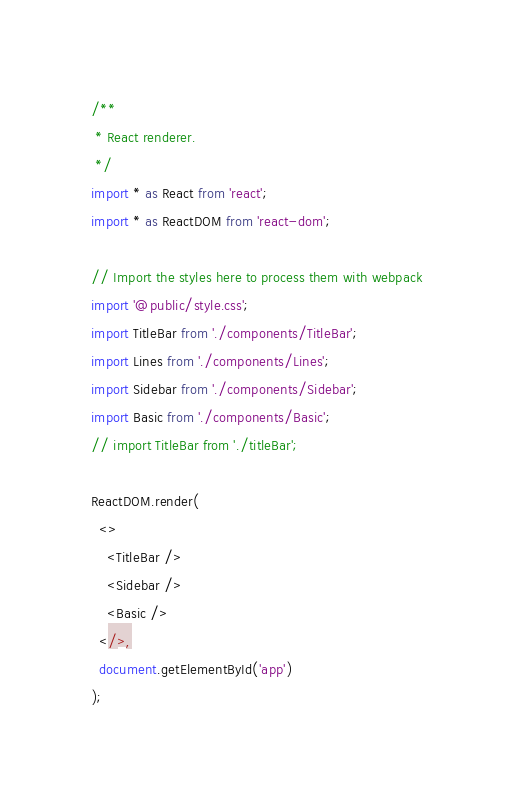Convert code to text. <code><loc_0><loc_0><loc_500><loc_500><_TypeScript_>/**
 * React renderer.
 */
import * as React from 'react';
import * as ReactDOM from 'react-dom';

// Import the styles here to process them with webpack
import '@public/style.css';
import TitleBar from './components/TitleBar';
import Lines from './components/Lines';
import Sidebar from './components/Sidebar';
import Basic from './components/Basic';
// import TitleBar from './titleBar';

ReactDOM.render(
  <>
    <TitleBar />
    <Sidebar />
    <Basic />
  </>,
  document.getElementById('app')
);
</code> 